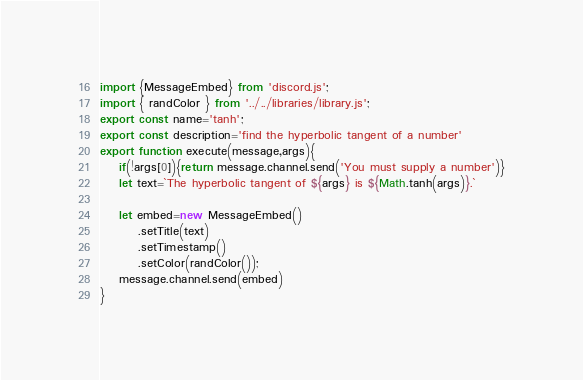Convert code to text. <code><loc_0><loc_0><loc_500><loc_500><_JavaScript_>import {MessageEmbed} from 'discord.js';
import { randColor } from '../../libraries/library.js';
export const name='tanh';
export const description='find the hyperbolic tangent of a number'
export function execute(message,args){
    if(!args[0]){return message.channel.send('You must supply a number')}
    let text=`The hyperbolic tangent of ${args} is ${Math.tanh(args)}.`

    let embed=new MessageEmbed()
        .setTitle(text)
        .setTimestamp()
        .setColor(randColor());
    message.channel.send(embed)
}</code> 